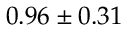Convert formula to latex. <formula><loc_0><loc_0><loc_500><loc_500>0 . 9 6 \pm 0 . 3 1</formula> 